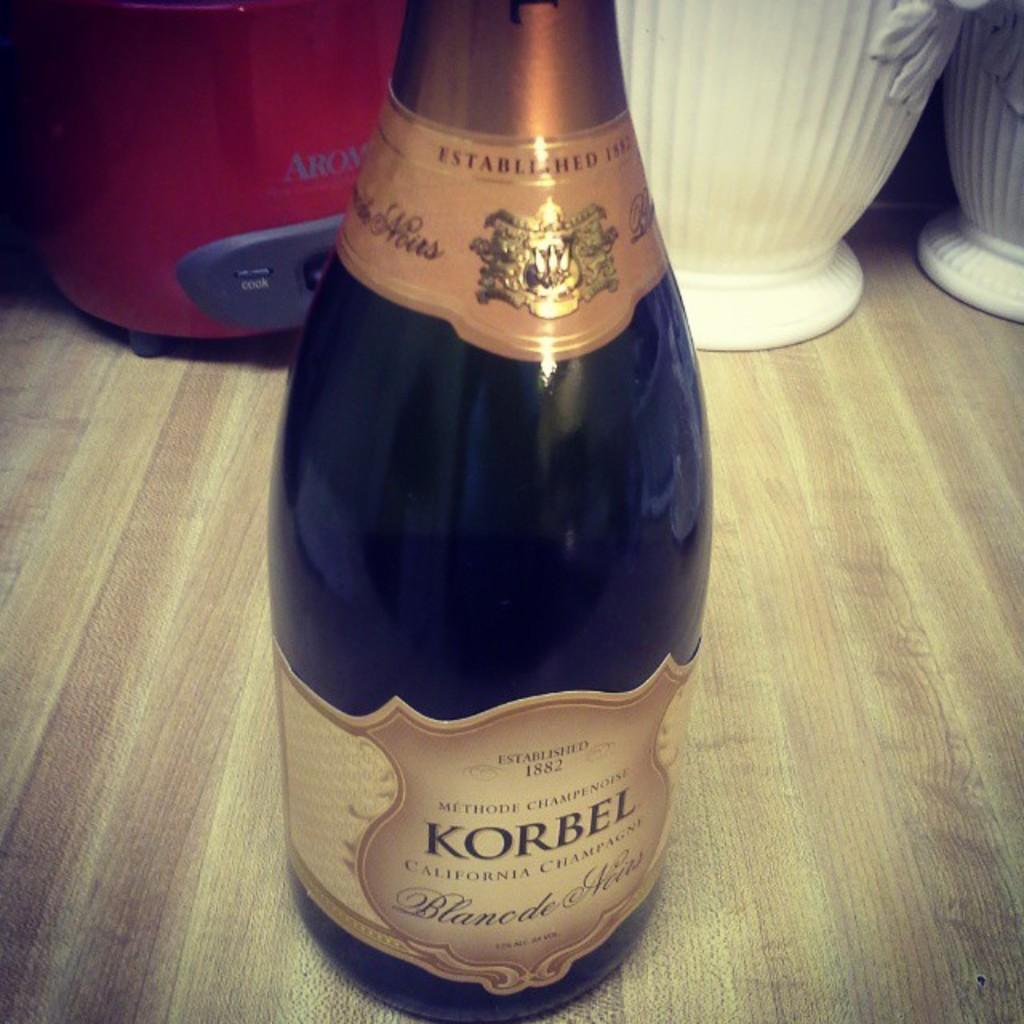<image>
Describe the image concisely. Black bottle of KORBEL on a wooden surface. 